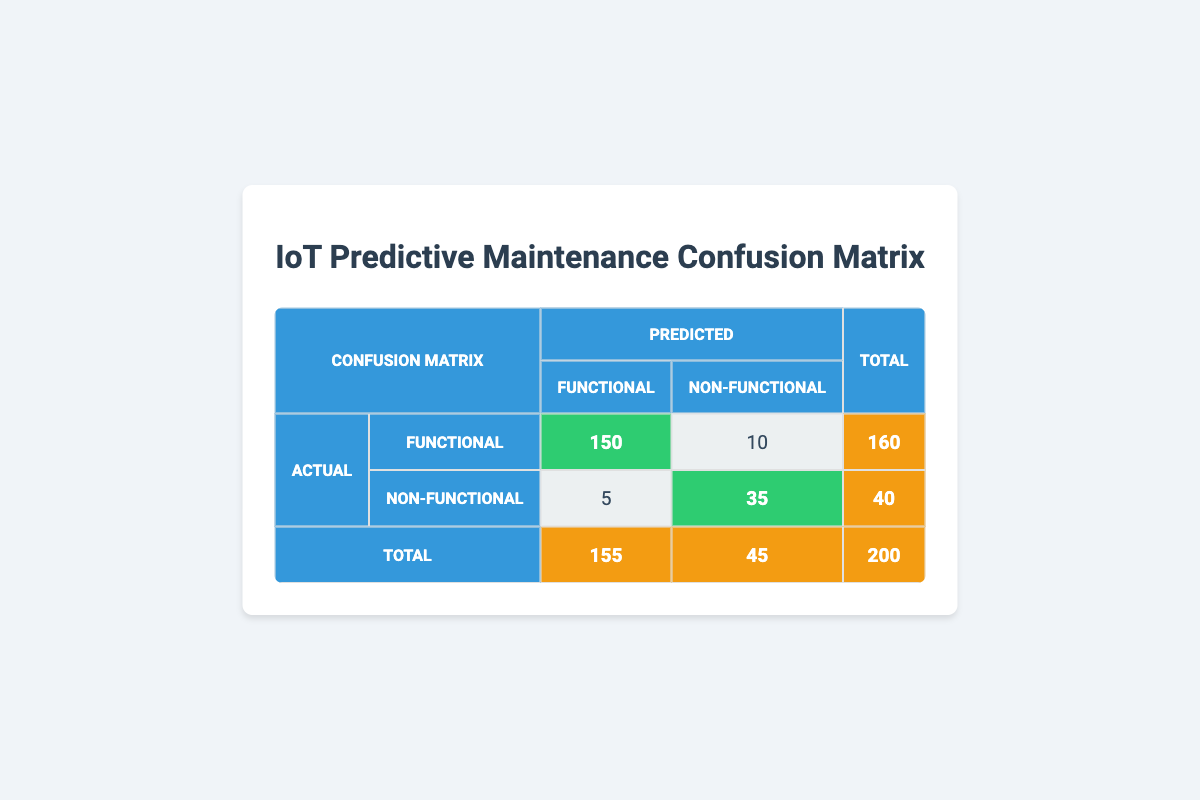What is the total number of actual Functional predictions? The table shows that there are 150 correct Functional predictions (True Positives) and 10 incorrect Functional predictions (False Positives). To find the total, we sum these two values: 150 + 10 = 160.
Answer: 160 How many predictions were made for Non-Functional devices? The table indicates a total of 40 predictions for Non-Functional devices: 5 correct Non-Functional predictions (True Negatives) and 35 incorrect Non-Functional predictions (False Negatives). The sum of these values gives us 5 + 35 = 40.
Answer: 40 What is the accuracy of the predictive maintenance model? Accuracy is calculated by dividing the sum of correctly identified predictions by the total predictions. Here, there are 150 + 35 = 185 correct predictions out of 200 total predictions. Therefore, accuracy is 185 / 200 = 0.925, or 92.5%.
Answer: 92.5% Is the number of Non-Functional predictions higher than Functional predictions? The table states there are 45 Non-Functional predictions and 155 Functional predictions. Since 45 is less than 155, the answer is no.
Answer: No How many total Functional predictions were made, and what percentage does it represent? The total number of Functional predictions is 160. To find the percentage, we divide by the total number of predictions: (160 / 200) * 100 = 80%.
Answer: 80% 